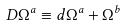<formula> <loc_0><loc_0><loc_500><loc_500>D \Omega ^ { a } \equiv d \Omega ^ { a } + \Omega ^ { b }</formula> 